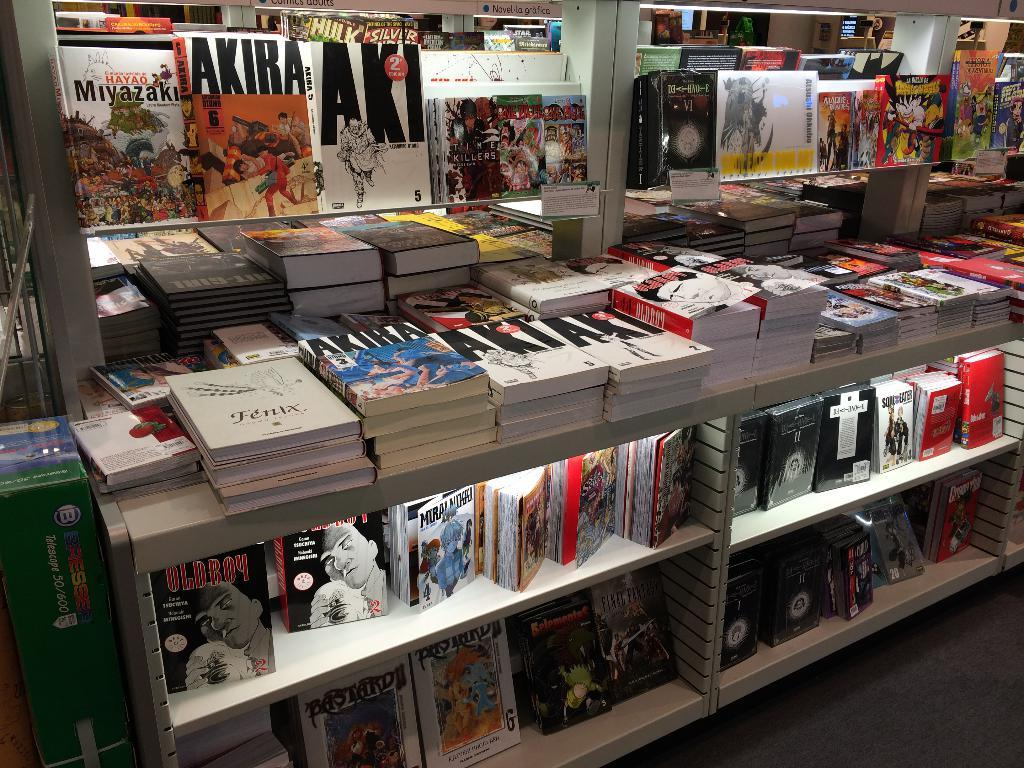<image>
Present a compact description of the photo's key features. A title of one of the many books on display is Akira. 